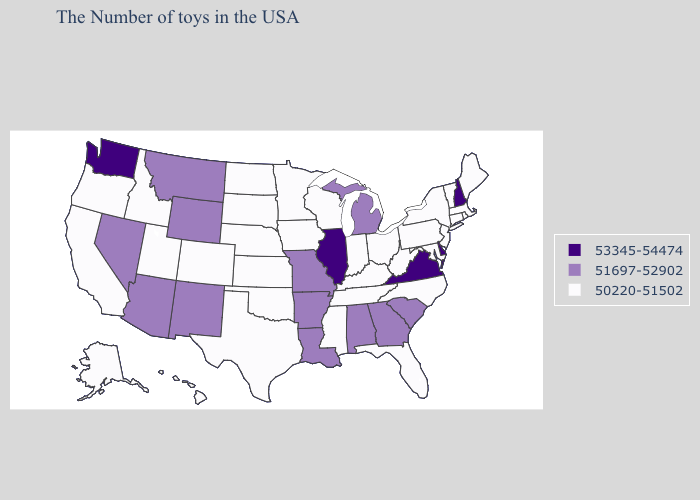Does Arkansas have a lower value than Illinois?
Answer briefly. Yes. What is the highest value in states that border New Mexico?
Concise answer only. 51697-52902. Name the states that have a value in the range 51697-52902?
Write a very short answer. South Carolina, Georgia, Michigan, Alabama, Louisiana, Missouri, Arkansas, Wyoming, New Mexico, Montana, Arizona, Nevada. Name the states that have a value in the range 50220-51502?
Concise answer only. Maine, Massachusetts, Rhode Island, Vermont, Connecticut, New York, New Jersey, Maryland, Pennsylvania, North Carolina, West Virginia, Ohio, Florida, Kentucky, Indiana, Tennessee, Wisconsin, Mississippi, Minnesota, Iowa, Kansas, Nebraska, Oklahoma, Texas, South Dakota, North Dakota, Colorado, Utah, Idaho, California, Oregon, Alaska, Hawaii. What is the value of Indiana?
Give a very brief answer. 50220-51502. What is the lowest value in the West?
Concise answer only. 50220-51502. What is the value of Alaska?
Answer briefly. 50220-51502. Name the states that have a value in the range 51697-52902?
Keep it brief. South Carolina, Georgia, Michigan, Alabama, Louisiana, Missouri, Arkansas, Wyoming, New Mexico, Montana, Arizona, Nevada. Name the states that have a value in the range 51697-52902?
Give a very brief answer. South Carolina, Georgia, Michigan, Alabama, Louisiana, Missouri, Arkansas, Wyoming, New Mexico, Montana, Arizona, Nevada. Is the legend a continuous bar?
Keep it brief. No. What is the lowest value in states that border Kentucky?
Concise answer only. 50220-51502. Which states have the lowest value in the Northeast?
Quick response, please. Maine, Massachusetts, Rhode Island, Vermont, Connecticut, New York, New Jersey, Pennsylvania. How many symbols are there in the legend?
Short answer required. 3. Is the legend a continuous bar?
Be succinct. No. Does the map have missing data?
Answer briefly. No. 